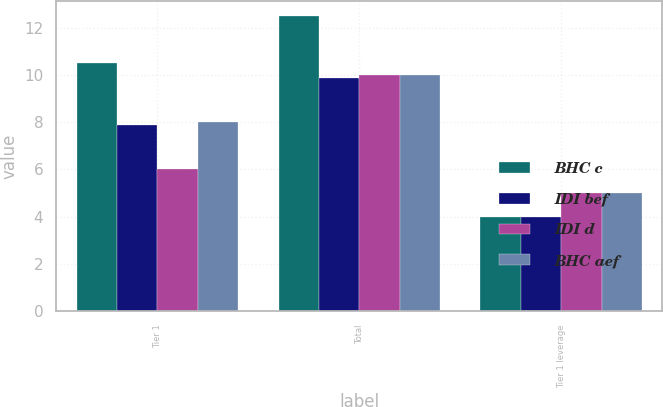<chart> <loc_0><loc_0><loc_500><loc_500><stacked_bar_chart><ecel><fcel>Tier 1<fcel>Total<fcel>Tier 1 leverage<nl><fcel>BHC c<fcel>10.5<fcel>12.5<fcel>4<nl><fcel>IDI bef<fcel>7.88<fcel>9.88<fcel>4<nl><fcel>IDI d<fcel>6<fcel>10<fcel>5<nl><fcel>BHC aef<fcel>8<fcel>10<fcel>5<nl></chart> 